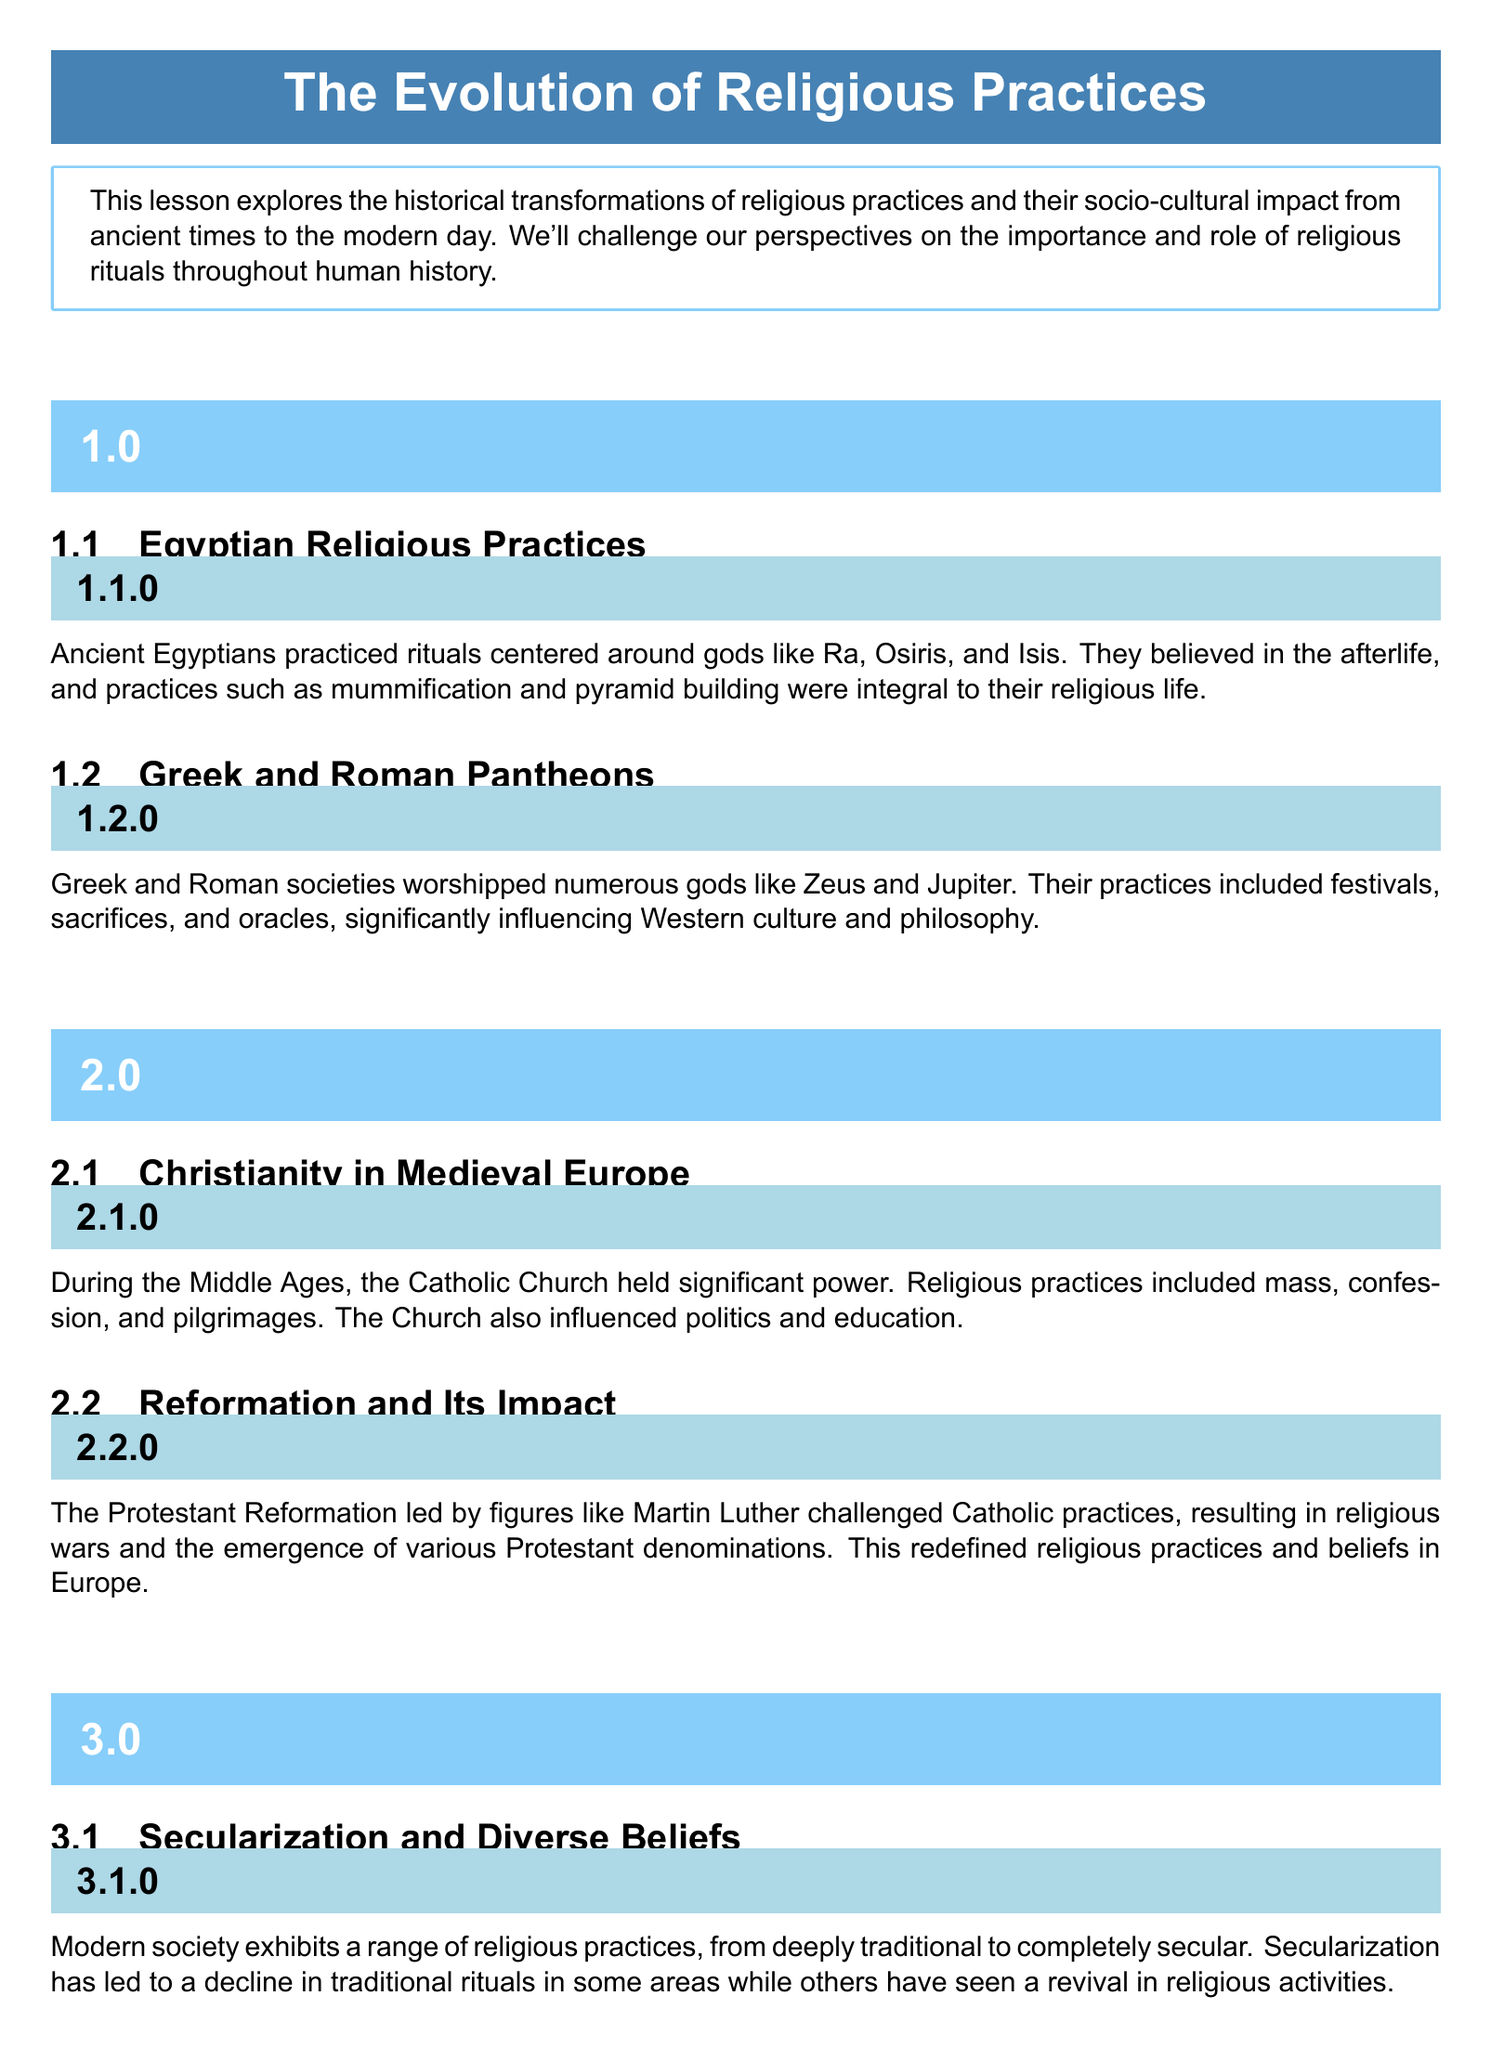What were the main gods of Ancient Egyptians? The document states that the Ancient Egyptians practiced rituals centered around gods like Ra, Osiris, and Isis.
Answer: Ra, Osiris, Isis What significant event did the Protestant Reformation lead to? The Protestant Reformation led to religious wars and the emergence of various Protestant denominations.
Answer: Religious wars Name one practice of Christianity in Medieval Europe. The document lists mass, confession, and pilgrimages as practices during this period; one example is mass.
Answer: Mass What is a modern trend in relation to religious practices? The document mentions that there is a growing trend towards interfaith dialogue and cooperation.
Answer: Interfaith dialogue How did the Catholic Church influence society during the Middle Ages? The document indicates that the Catholic Church held significant power and influenced politics and education.
Answer: Politics and education What has contributed to the decline of traditional rituals in some areas? The document states that secularization has led to a decline in traditional rituals in some areas.
Answer: Secularization What impact did the Greek and Roman pantheons have? The document discusses that their practices significantly influenced Western culture and philosophy.
Answer: Western culture and philosophy 